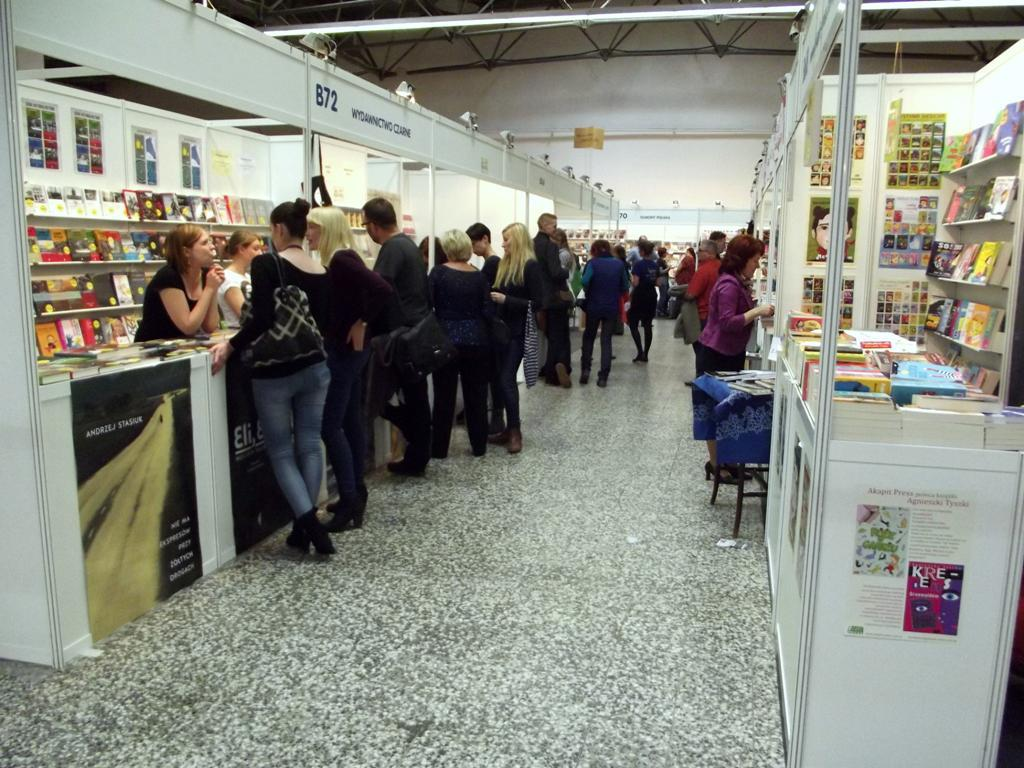What items can be seen inside the building in the image? There are stoles inside the building. What can be observed around the building in the image? There are people visible around the building. Can you see a basket filled with flames in the image? There is no basket filled with flames present in the image. Is there a tiger visible inside the building in the image? There is no tiger visible inside the building in the image. 